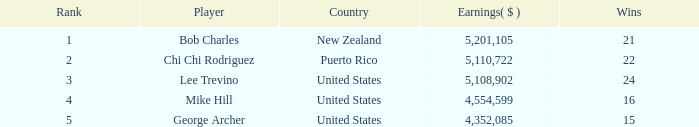What is the smallest earnings($) necessary to obtain a wins value of 22 and a rank under 2? None. 